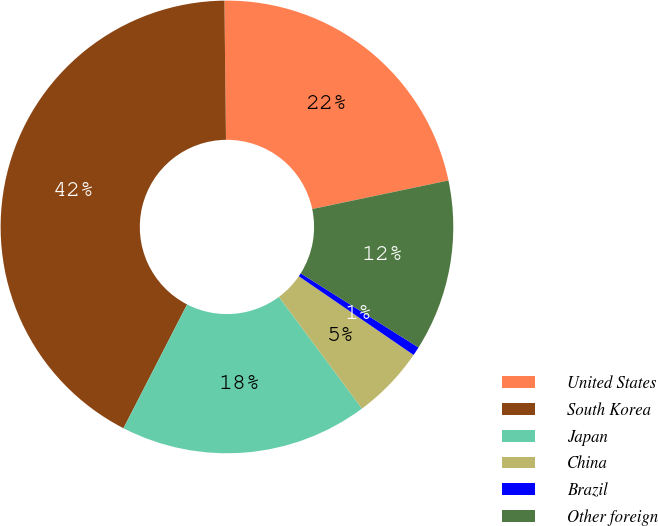Convert chart. <chart><loc_0><loc_0><loc_500><loc_500><pie_chart><fcel>United States<fcel>South Korea<fcel>Japan<fcel>China<fcel>Brazil<fcel>Other foreign<nl><fcel>21.89%<fcel>42.27%<fcel>17.73%<fcel>5.26%<fcel>0.63%<fcel>12.23%<nl></chart> 